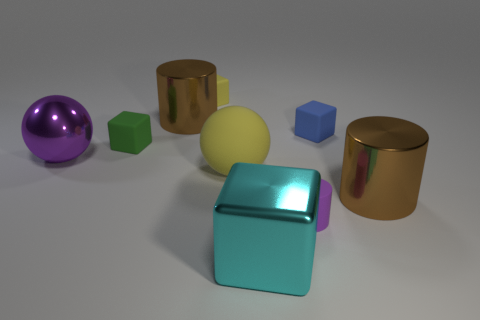Are there an equal number of green matte blocks right of the yellow block and small yellow rubber cubes in front of the matte ball?
Offer a very short reply. Yes. What is the size of the blue thing that is the same shape as the large cyan thing?
Your response must be concise. Small. How big is the metal thing that is both behind the small matte cylinder and right of the tiny yellow matte block?
Provide a succinct answer. Large. There is a big purple metallic sphere; are there any big brown things to the left of it?
Offer a terse response. No. How many objects are either matte things that are behind the large yellow ball or brown rubber spheres?
Your answer should be compact. 3. How many brown metal objects are in front of the large brown metal object that is in front of the purple shiny object?
Offer a very short reply. 0. Are there fewer small blue blocks behind the blue matte thing than purple cylinders that are to the left of the small yellow matte object?
Give a very brief answer. No. The yellow rubber thing that is in front of the big brown thing that is to the left of the yellow matte ball is what shape?
Your answer should be very brief. Sphere. What number of other objects are there of the same material as the large yellow object?
Provide a short and direct response. 4. Are there any other things that have the same size as the purple matte cylinder?
Your answer should be very brief. Yes. 